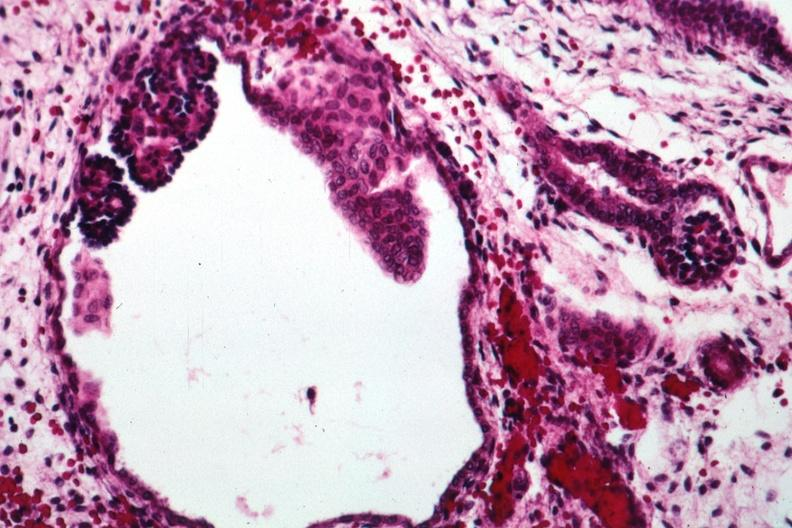what does this image show?
Answer the question using a single word or phrase. Abortive glomeruli 